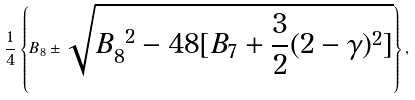Convert formula to latex. <formula><loc_0><loc_0><loc_500><loc_500>\frac { 1 } { 4 } \left \{ B _ { 8 } \pm \sqrt { B _ { 8 } ^ { \ 2 } - 4 8 [ B _ { 7 } + \frac { 3 } { 2 } ( 2 - \gamma ) ^ { 2 } ] } \right \} ,</formula> 